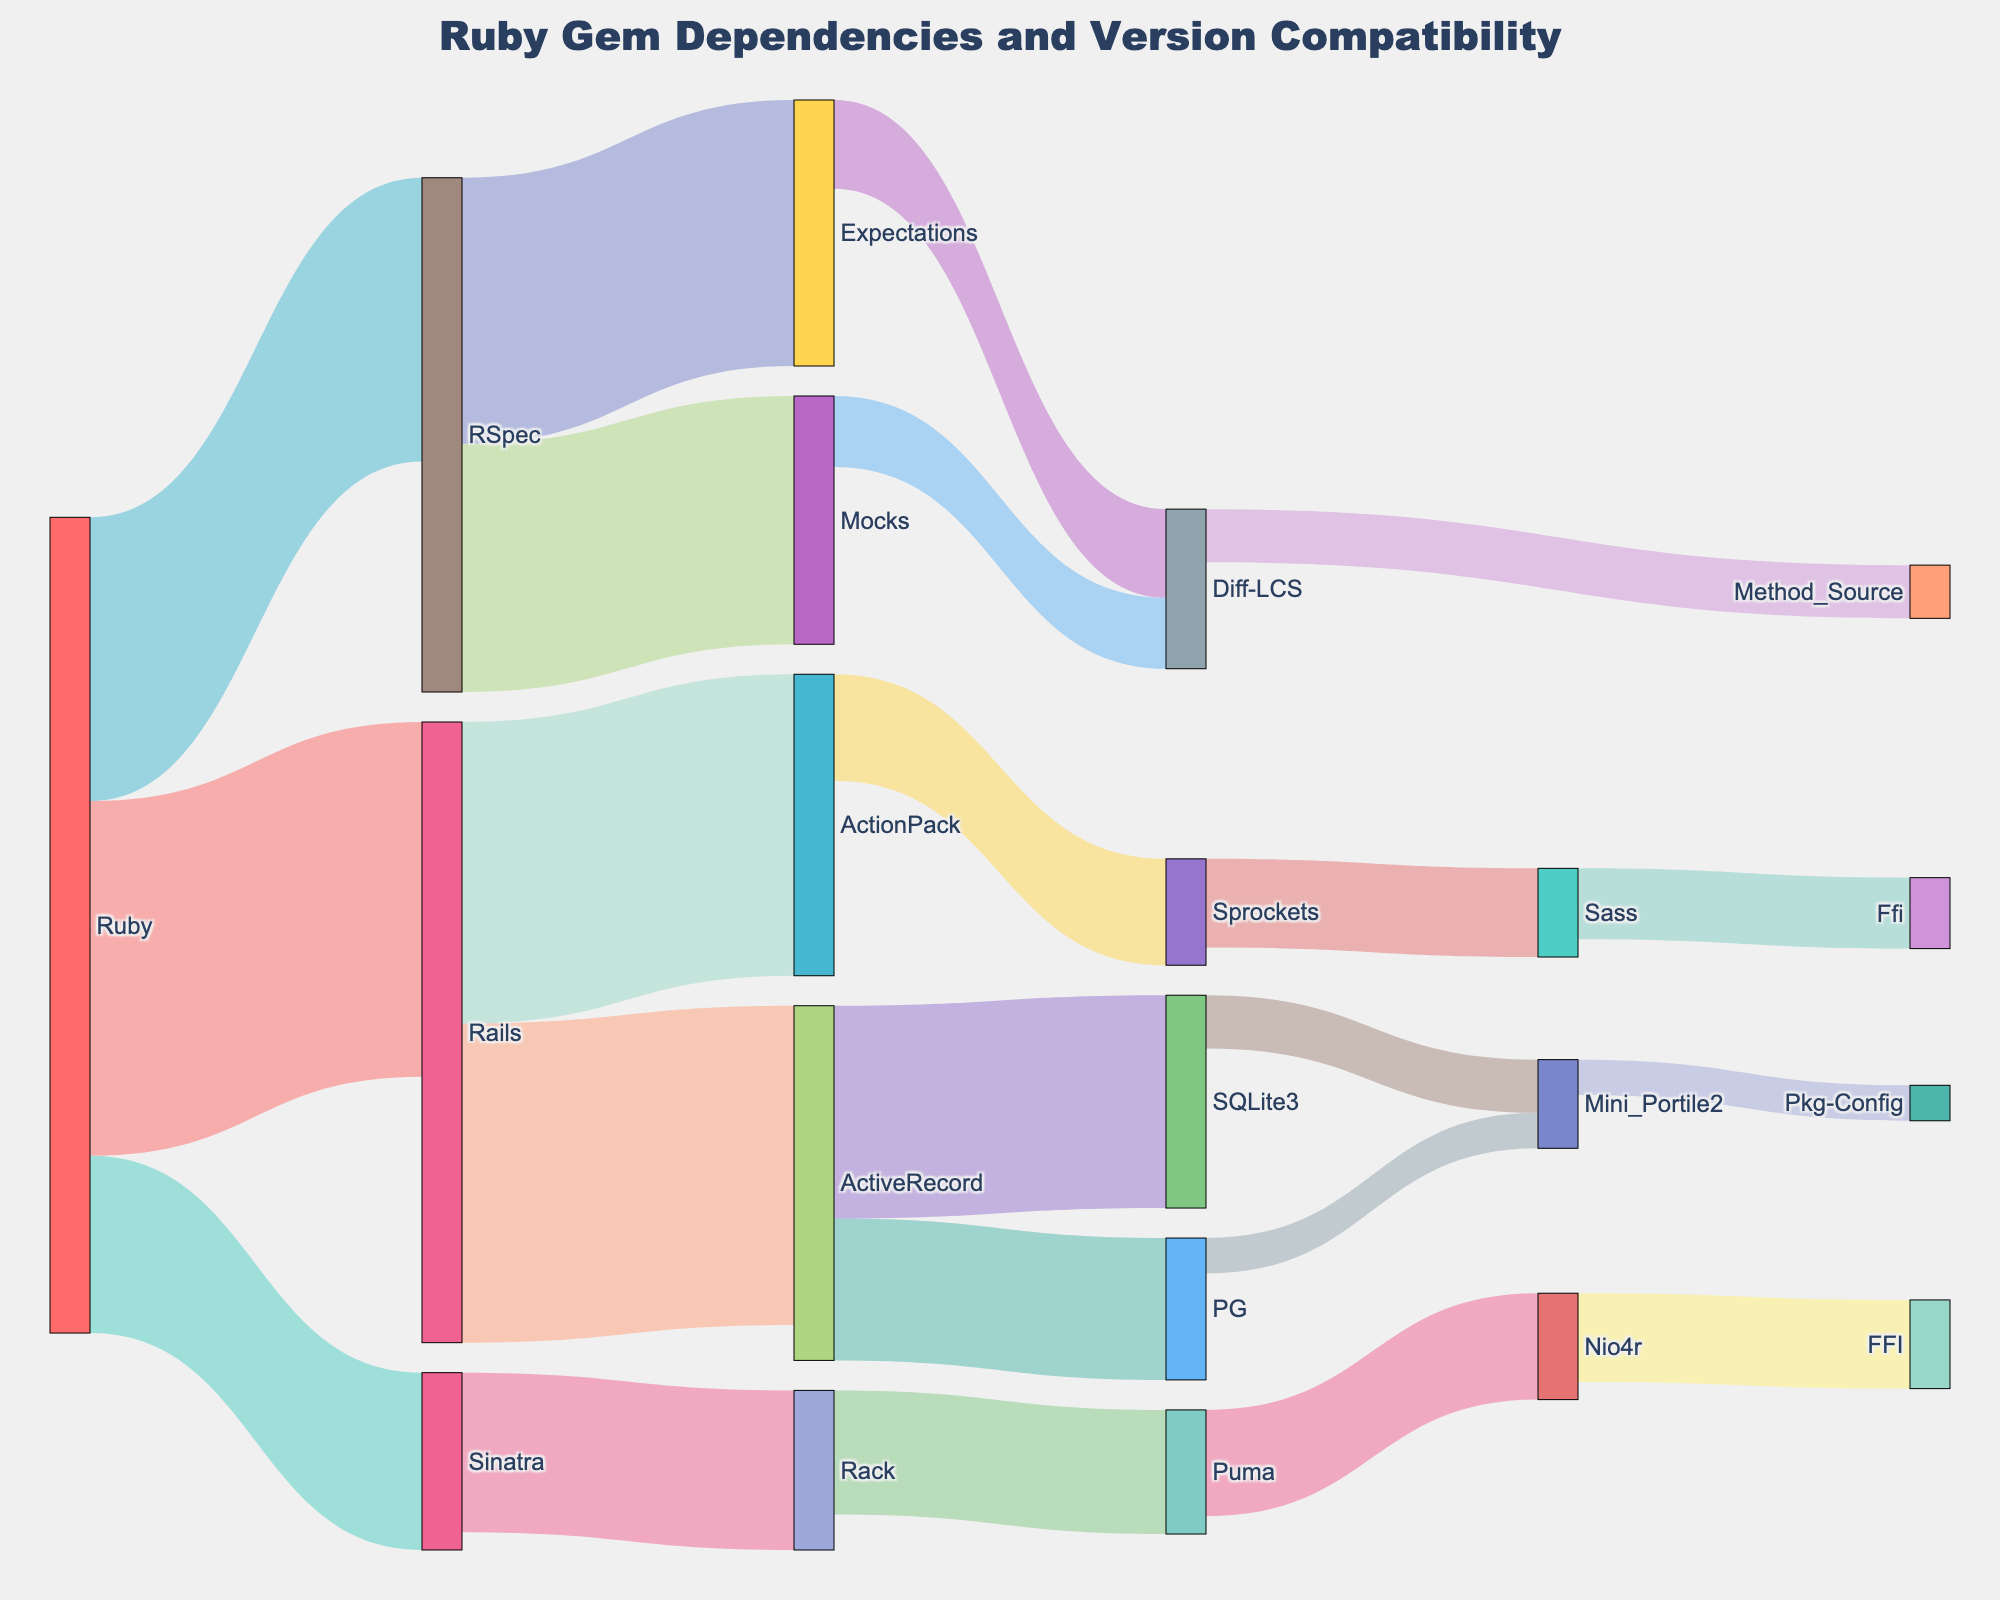how many connections start from Ruby in the Sankey diagram? To find the number of connections starting from Ruby, look for all the links where Ruby is the source. There are connections to Rails, Sinatra, and RSpec.
Answer: 3 which two nodes contribute the most flow to Rails? To determine the nodes contributing the most flow to Rails, observe the links connected to Rails. The values are ActiveRecord (90) and ActionPack (85). These two nodes contribute the most flow to Rails.
Answer: ActiveRecord and ActionPack compare the flows from RSpec to its target nodes. Which target node receives more flow? Identify the links from RSpec to its target nodes. The values are Mocks (70) and Expectations (75). Expectations receives more flow.
Answer: Expectations what is the total flow from ActiveRecord to its target nodes? Sum the values of links originating from ActiveRecord to its target nodes. The values are SQLite3 (60) and PG (40). The total flow is 60 + 40 = 100.
Answer: 100 how much flow is contributed from Sinatra to rack? Look at the link from Sinatra to Rack and note the value. The value of flow is 45.
Answer: 45 what is the smallest flow value in the diagram? Look for the smallest value among all the links. The smallest flow value is 10, which is contributed by Mini_Portile2 to Pkg-Config and PG to Mini_Portile2.
Answer: 10 which node has the highest number of incoming connections? Count the number of connections entering each node. Diff-LCS has the highest number with 2 incoming connections (Mocks and Expectations).
Answer: Diff-LCS how many total nodes are present in the Sankey diagram? Count all the unique nodes in the diagram. There are 21 unique nodes.
Answer: 21 compare the total incoming flow to RSpec and Rails. Which node has a higher total incoming flow? For RSpec, the incoming flow is 80 from Ruby. For Rails, the incoming flow is 100 from Ruby. Rails has a higher total incoming flow.
Answer: Rails identify all nodes that have outgoing connections but no incoming connections. Look for nodes that only act as sources and not targets. These nodes are Ruby.
Answer: Ruby 